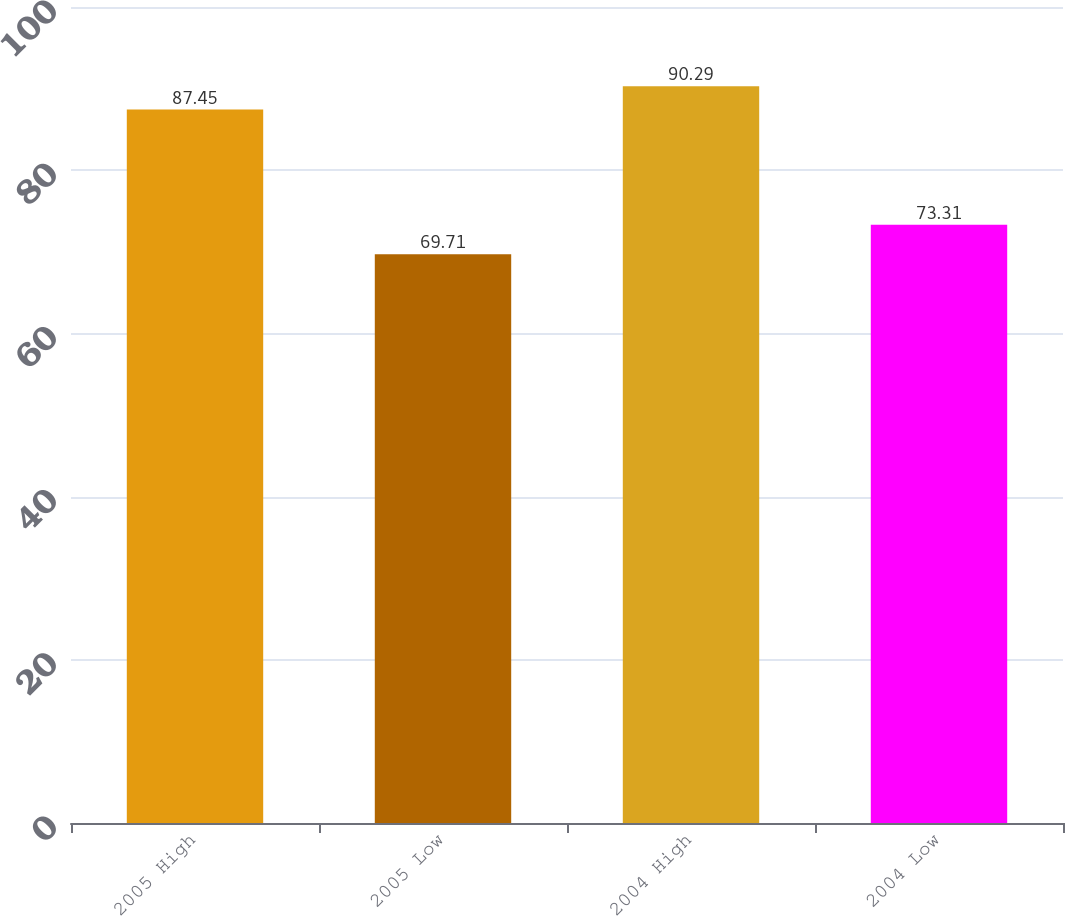Convert chart. <chart><loc_0><loc_0><loc_500><loc_500><bar_chart><fcel>2005 High<fcel>2005 Low<fcel>2004 High<fcel>2004 Low<nl><fcel>87.45<fcel>69.71<fcel>90.29<fcel>73.31<nl></chart> 